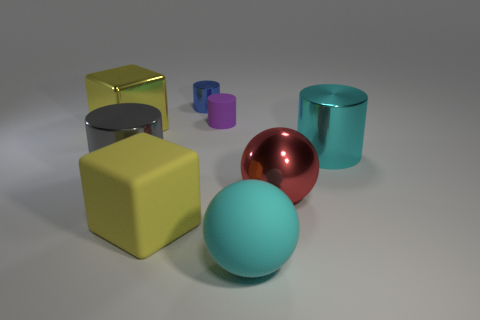The metallic cylinder in front of the cyan object behind the cyan rubber object is what color?
Your answer should be compact. Gray. Does the matte cylinder have the same size as the cyan rubber thing?
Your answer should be compact. No. How many cylinders are either large yellow metal things or small matte objects?
Make the answer very short. 1. How many small blue metallic cylinders are left of the big red metallic thing that is to the right of the gray object?
Your answer should be very brief. 1. Do the blue thing and the big cyan matte object have the same shape?
Your response must be concise. No. What size is the other cyan thing that is the same shape as the tiny shiny thing?
Provide a short and direct response. Large. The matte object in front of the big rubber object on the left side of the small purple rubber thing is what shape?
Offer a terse response. Sphere. What size is the gray cylinder?
Ensure brevity in your answer.  Large. What shape is the gray thing?
Offer a very short reply. Cylinder. Do the blue shiny thing and the big yellow thing in front of the red shiny ball have the same shape?
Provide a succinct answer. No. 